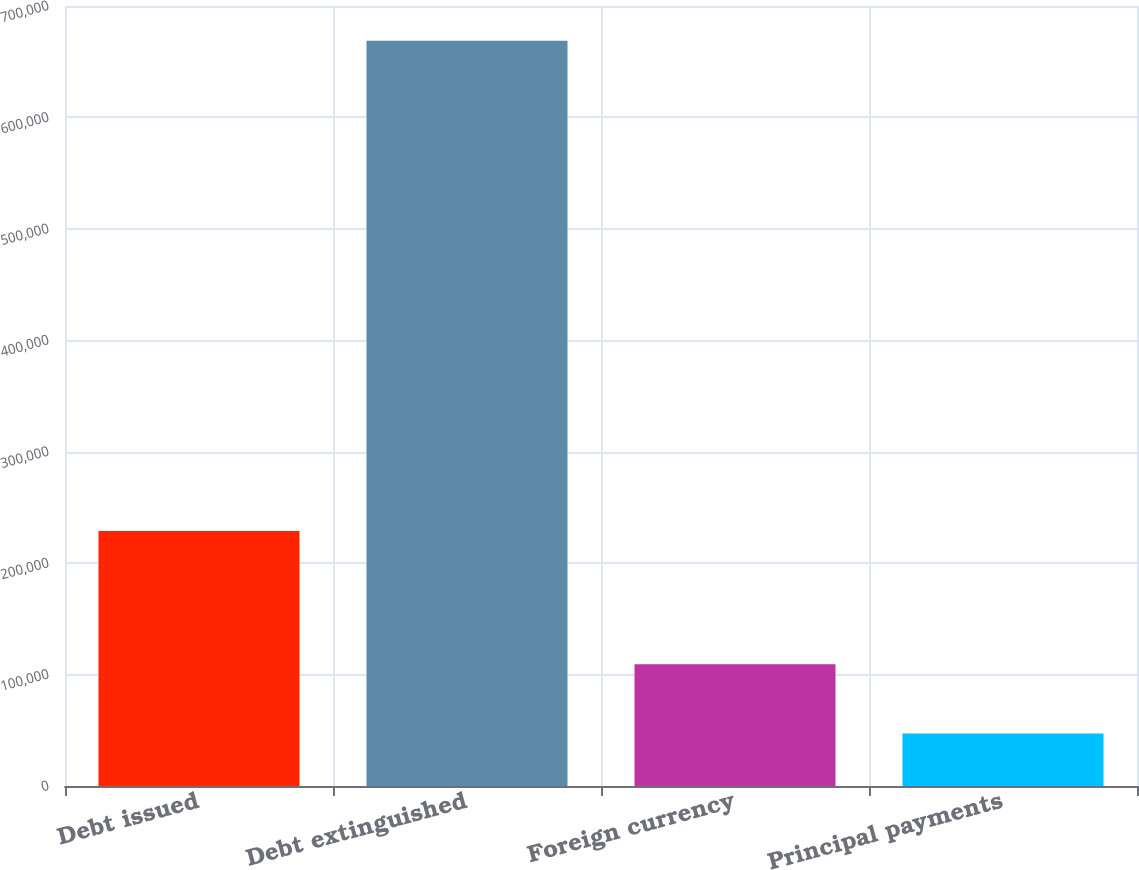Convert chart. <chart><loc_0><loc_0><loc_500><loc_500><bar_chart><fcel>Debt issued<fcel>Debt extinguished<fcel>Foreign currency<fcel>Principal payments<nl><fcel>228772<fcel>668804<fcel>109318<fcel>47153<nl></chart> 